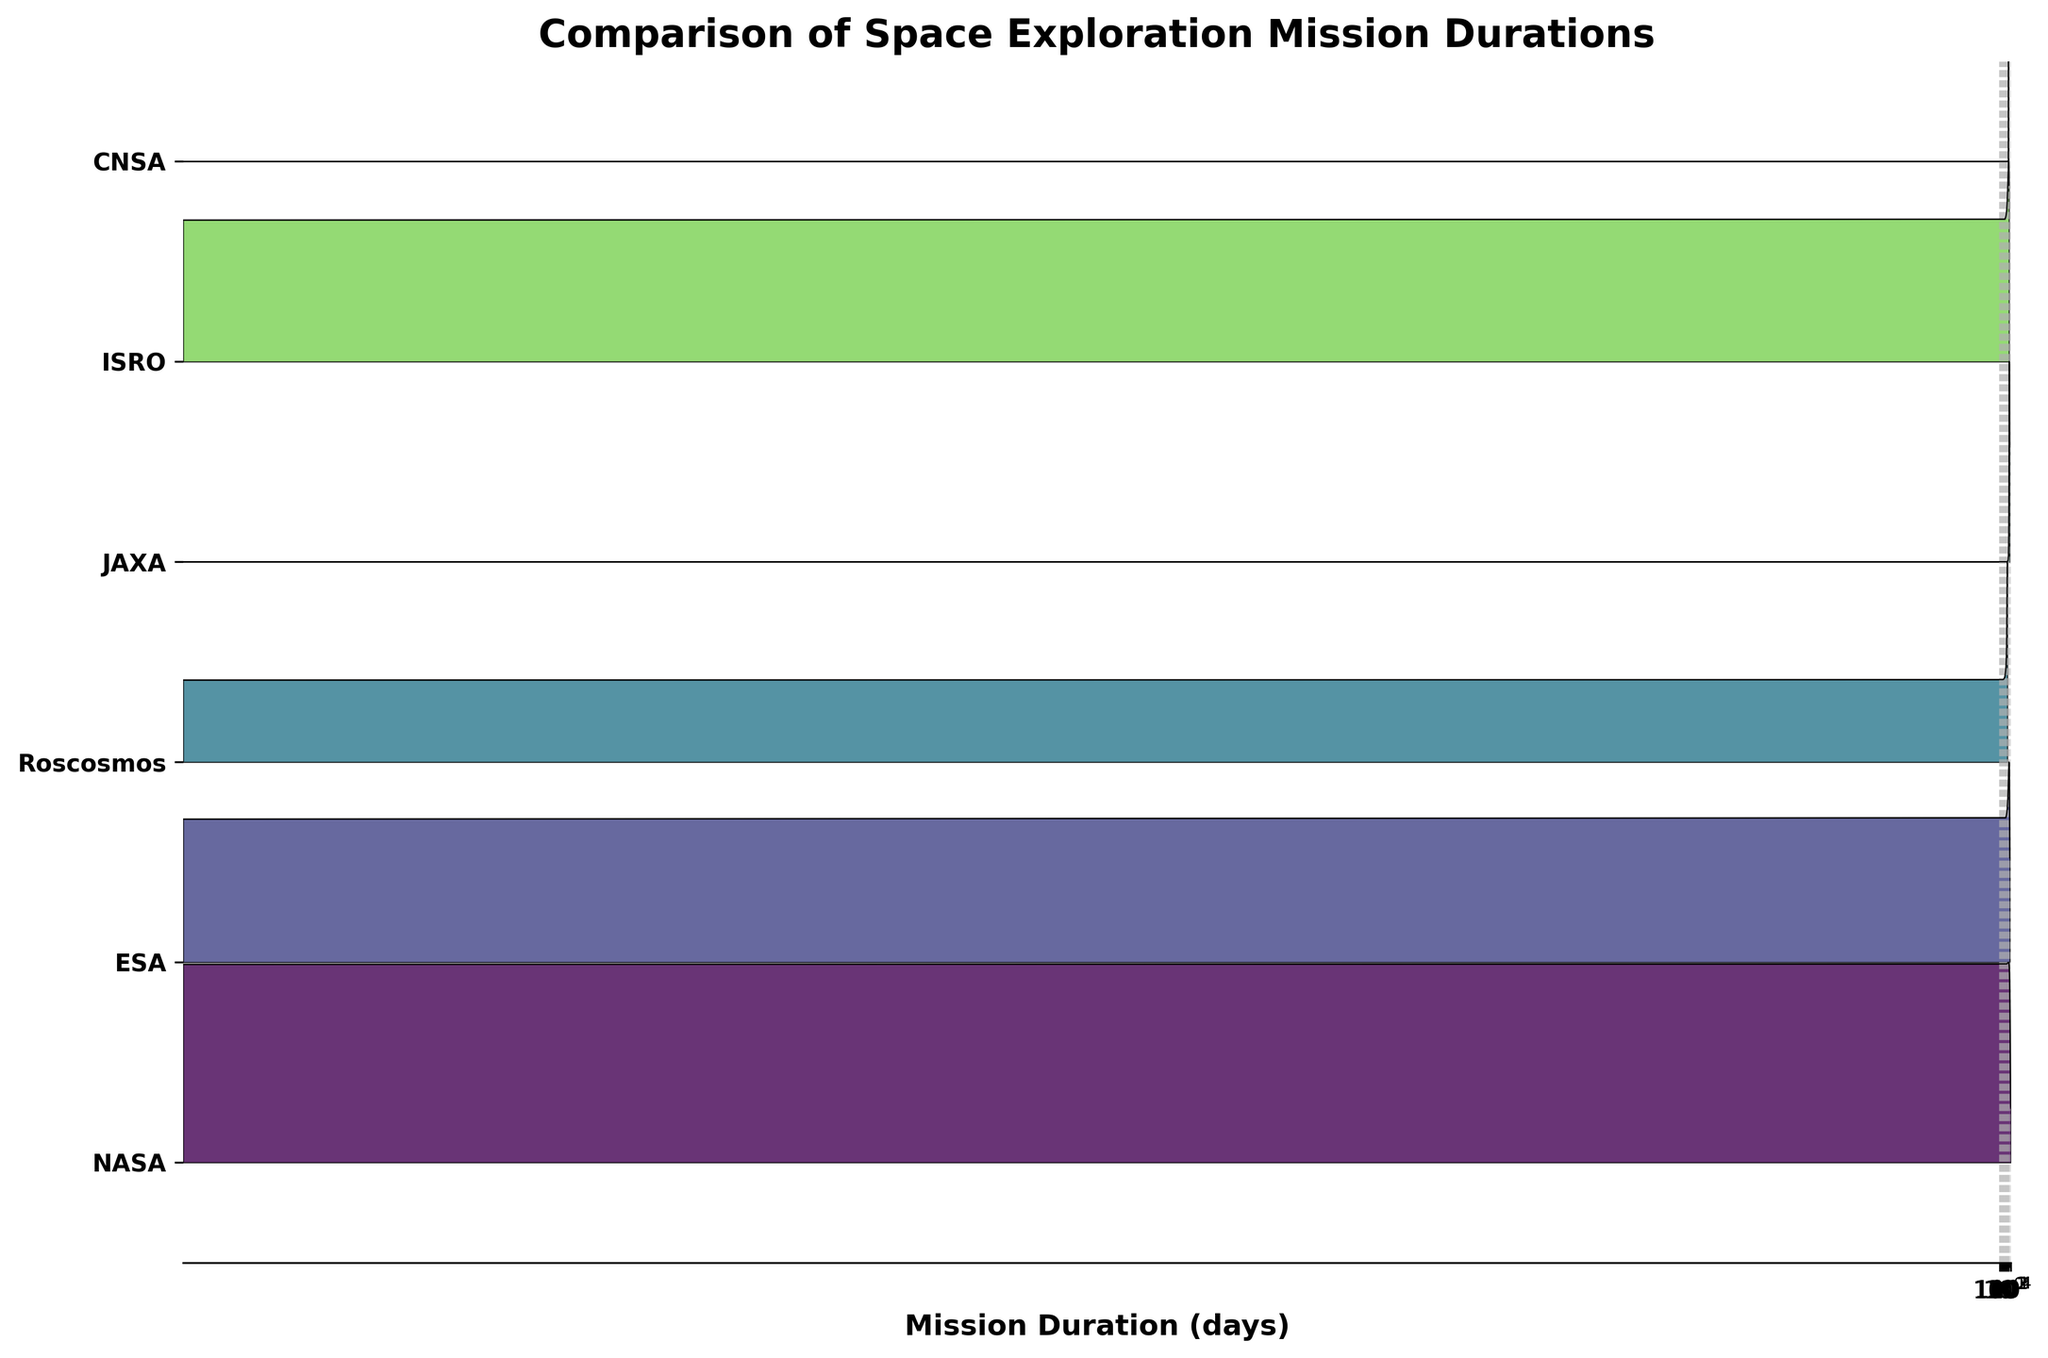what is the title of the plot? The title can be found at the top of the figure. In this plot, it is written prominently to describe what the visual represents.
Answer: Comparison of Space Exploration Mission Durations What is the number of space agencies represented in the plot? The number of space agencies can be determined by counting the unique labels on the y-axis. Each label represents one agency.
Answer: 5 Which space agency has missions with the longest durations? Look at the ridgelines and observe which one extends the most into the right side of the x-axis. The agency with the longest extending ridgeline represents the longest mission durations.
Answer: NASA How does the duration distribution of NASA missions compare to that of ESA missions? Compare the length and density of the ridgelines for NASA and ESA. NASA's ridgeline will likely extend further with more dense areas over longer durations if their missions tend to last longer.
Answer: NASA missions typically have longer durations than ESA missions Which space agency has the highest density of missions around the 10^2 days mark? Look at the peak densities around the mark for 100 days (10^2). The agency whose ridgeline has the highest peak in this range is the answer.
Answer: Roscosmos Which agency has the shortest-duration mission, and what is that duration? Identify the leftmost points on the ridgelines. The shortest duration will be the point closest to zero. Check which agency this point belongs to.
Answer: Roscosmos, 6 days Among the represented space agencies, which one has the broadest range of mission durations? This can be assessed by observing the spread of the ridgelines across the x-axis. The agency with the ridgeline that spans the widest range has the broadest range of durations.
Answer: NASA 